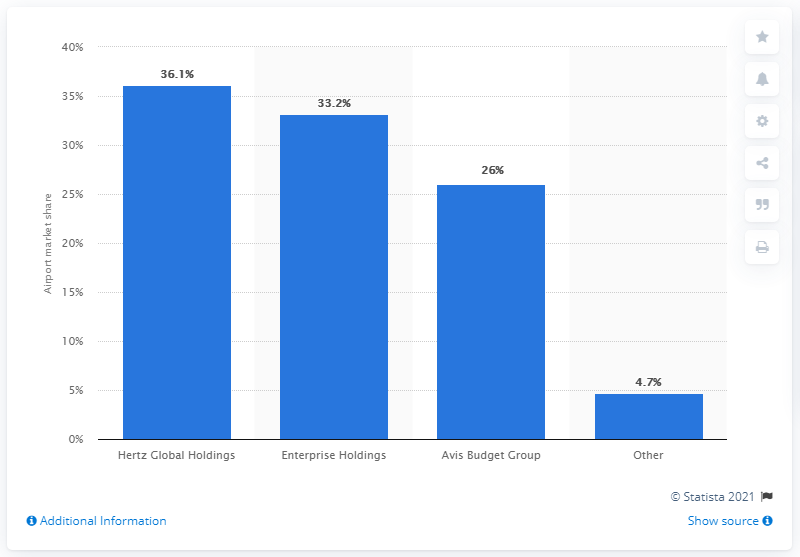Outline some significant characteristics in this image. In 2013, Hertz Global Holdings had the largest share of the airport car rental market. In 2013, Hertz Global Holdings held a market share of 36.1% in the airport car rental industry. 